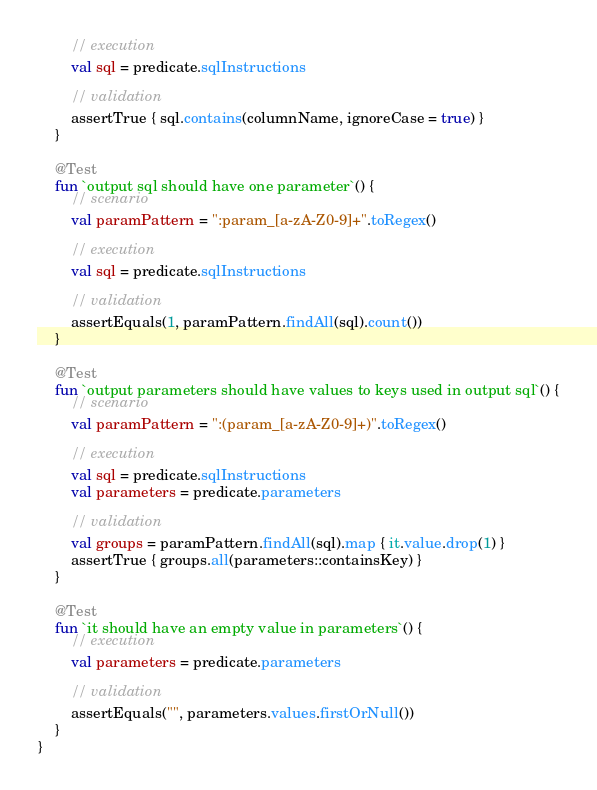Convert code to text. <code><loc_0><loc_0><loc_500><loc_500><_Kotlin_>        // execution
        val sql = predicate.sqlInstructions

        // validation
        assertTrue { sql.contains(columnName, ignoreCase = true) }
    }

    @Test
    fun `output sql should have one parameter`() {
        // scenario
        val paramPattern = ":param_[a-zA-Z0-9]+".toRegex()

        // execution
        val sql = predicate.sqlInstructions

        // validation
        assertEquals(1, paramPattern.findAll(sql).count())
    }

    @Test
    fun `output parameters should have values to keys used in output sql`() {
        // scenario
        val paramPattern = ":(param_[a-zA-Z0-9]+)".toRegex()

        // execution
        val sql = predicate.sqlInstructions
        val parameters = predicate.parameters

        // validation
        val groups = paramPattern.findAll(sql).map { it.value.drop(1) }
        assertTrue { groups.all(parameters::containsKey) }
    }

    @Test
    fun `it should have an empty value in parameters`() {
        // execution
        val parameters = predicate.parameters

        // validation
        assertEquals("", parameters.values.firstOrNull())
    }
}</code> 